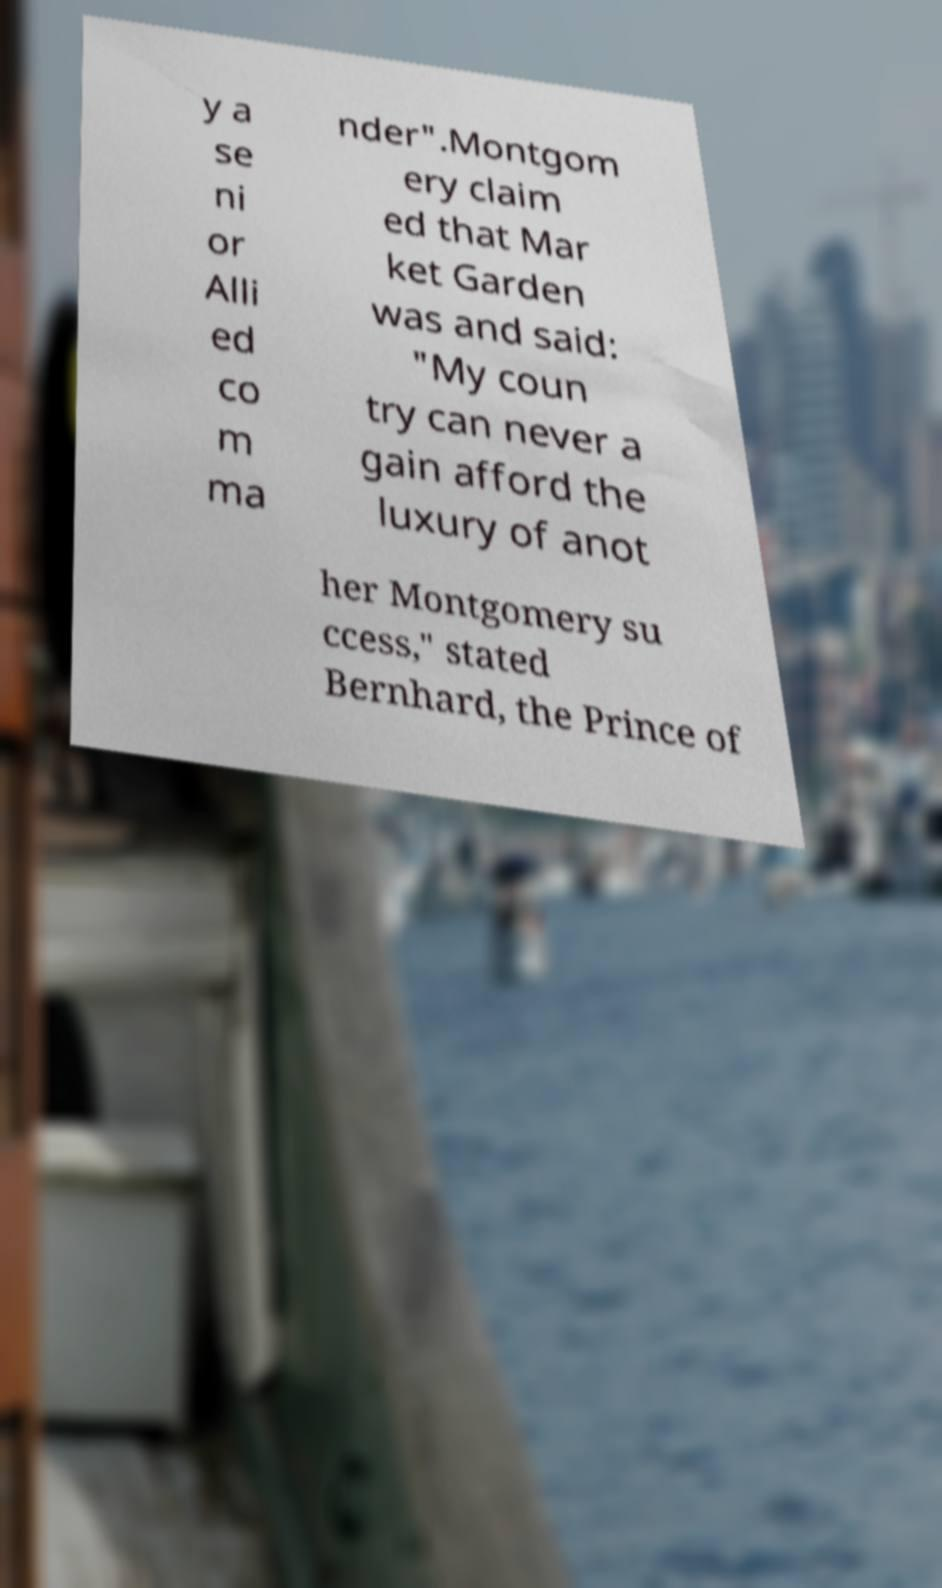What messages or text are displayed in this image? I need them in a readable, typed format. y a se ni or Alli ed co m ma nder".Montgom ery claim ed that Mar ket Garden was and said: "My coun try can never a gain afford the luxury of anot her Montgomery su ccess," stated Bernhard, the Prince of 